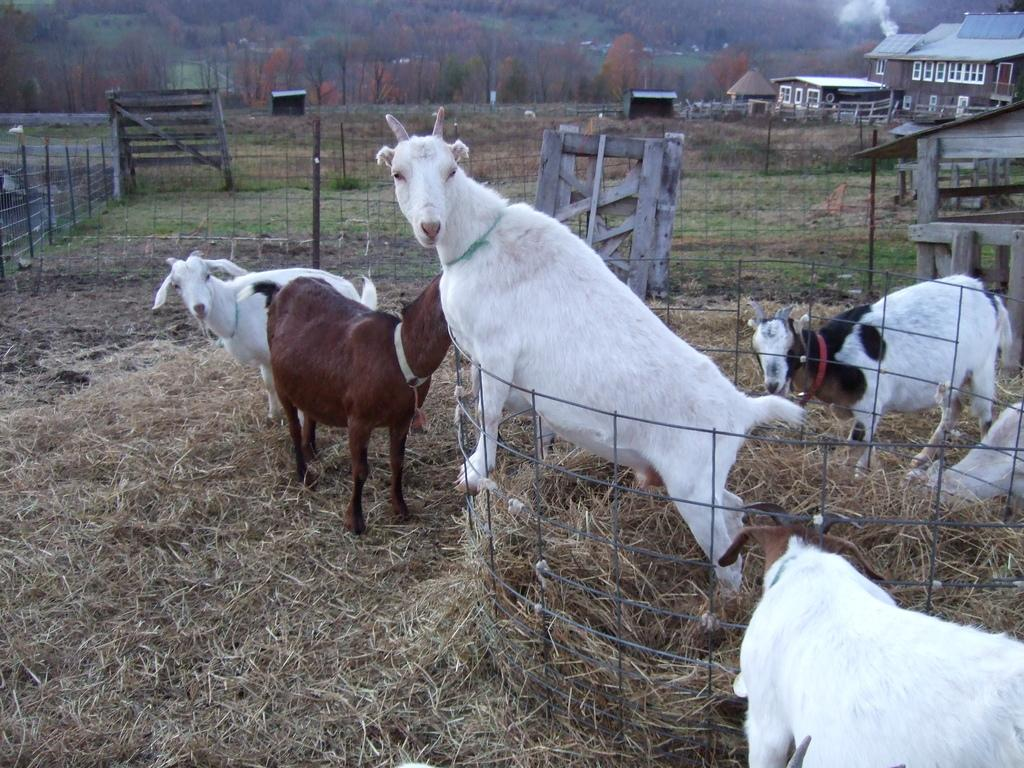What type of animals can be seen in the image? There are animals visible on the grass in the image. What is located in the middle of the image? There is a fence in the middle of the image. What type of structures can be seen in the image? There are houses visible in the image. What type of vegetation is visible at the top of the image? Trees are visible at the top of the image. What is the income of the secretary in the image? There is no secretary or mention of income in the image. How does the health of the animals in the image compare to the health of the trees? The image does not provide any information about the health of the animals or trees, so it cannot be determined. 